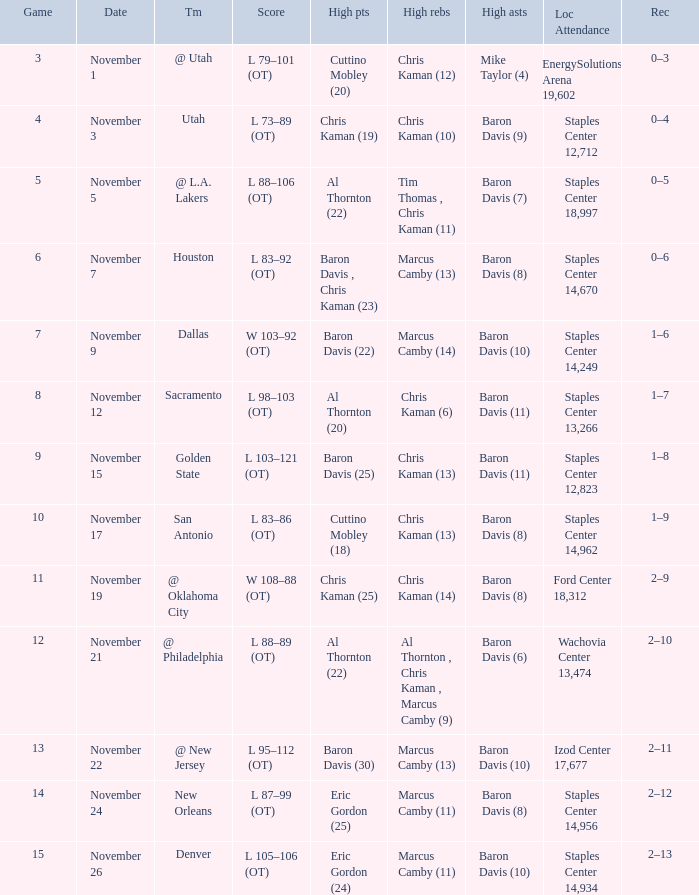Name the high assists for  l 98–103 (ot) Baron Davis (11). 